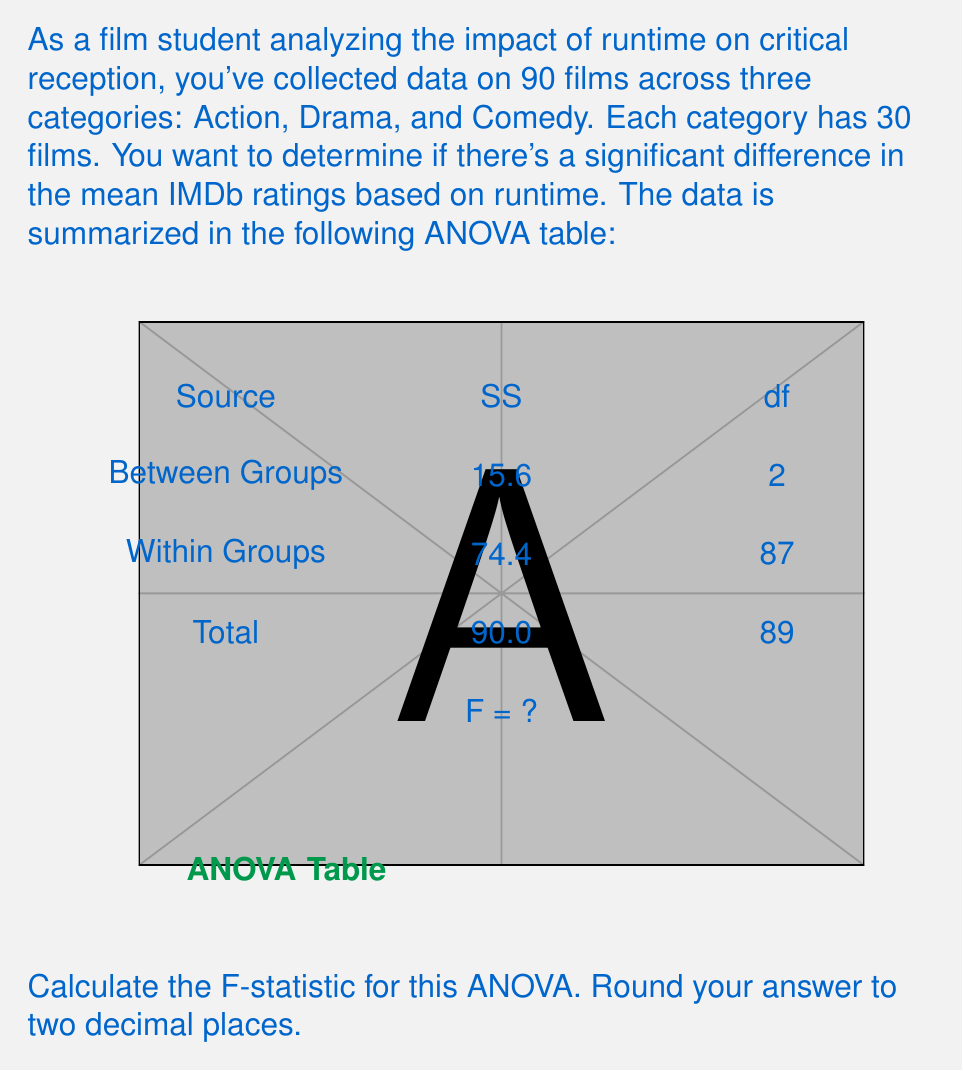What is the answer to this math problem? To calculate the F-statistic for this ANOVA, we'll follow these steps:

1) First, let's identify the components of the ANOVA table:
   - SS(Between) = 15.6
   - SS(Within) = 74.4
   - df(Between) = 2
   - df(Within) = 87

2) Calculate the Mean Square (MS) for Between and Within groups:
   
   MS(Between) = SS(Between) / df(Between)
   $$ MS(Between) = \frac{15.6}{2} = 7.8 $$
   
   MS(Within) = SS(Within) / df(Within)
   $$ MS(Within) = \frac{74.4}{87} \approx 0.8552 $$

3) The F-statistic is the ratio of MS(Between) to MS(Within):

   $$ F = \frac{MS(Between)}{MS(Within)} = \frac{7.8}{0.8552} \approx 9.1208 $$

4) Rounding to two decimal places:
   F ≈ 9.12

This F-statistic can be used to determine if there's a significant difference in mean IMDb ratings based on runtime across the three film categories.
Answer: 9.12 